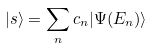<formula> <loc_0><loc_0><loc_500><loc_500>| s \rangle = \sum _ { n } c _ { n } | \Psi ( E _ { n } ) \rangle</formula> 